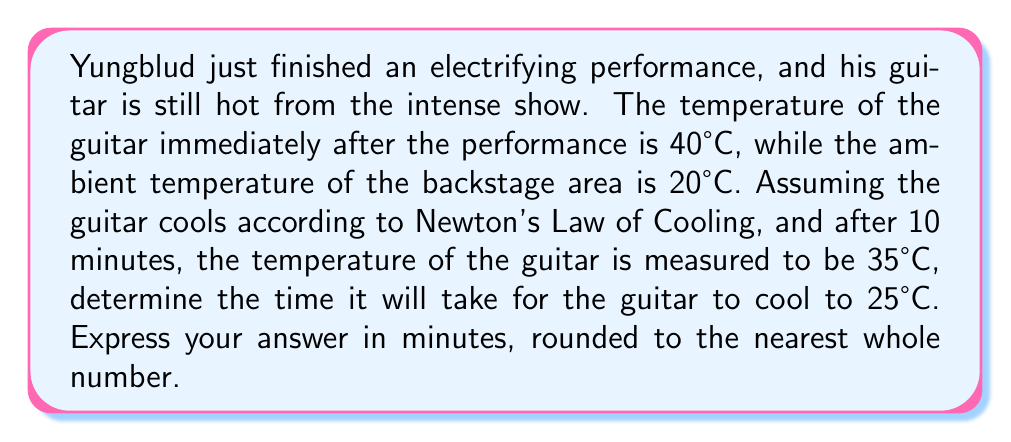Show me your answer to this math problem. Let's approach this problem step-by-step using Newton's Law of Cooling:

1) Newton's Law of Cooling is given by the differential equation:

   $$\frac{dT}{dt} = -k(T - T_a)$$

   where $T$ is the temperature of the object, $T_a$ is the ambient temperature, $t$ is time, and $k$ is the cooling constant.

2) The solution to this equation is:

   $$T(t) = T_a + (T_0 - T_a)e^{-kt}$$

   where $T_0$ is the initial temperature.

3) We're given:
   - $T_0 = 40°C$ (initial temperature)
   - $T_a = 20°C$ (ambient temperature)
   - After 10 minutes, $T = 35°C$

4) Let's use the data point at 10 minutes to find $k$:

   $$35 = 20 + (40 - 20)e^{-k(10)}$$
   $$15 = 20e^{-10k}$$
   $$\frac{3}{4} = e^{-10k}$$
   $$\ln(\frac{3}{4}) = -10k$$
   $$k = -\frac{\ln(\frac{3}{4})}{10} \approx 0.0288$$

5) Now that we have $k$, we can use the equation to find the time when $T = 25°C$:

   $$25 = 20 + (40 - 20)e^{-0.0288t}$$
   $$5 = 20e^{-0.0288t}$$
   $$\frac{1}{4} = e^{-0.0288t}$$
   $$\ln(\frac{1}{4}) = -0.0288t$$
   $$t = -\frac{\ln(\frac{1}{4})}{0.0288} \approx 48.04$$

6) Rounding to the nearest whole number, we get 48 minutes.
Answer: 48 minutes 